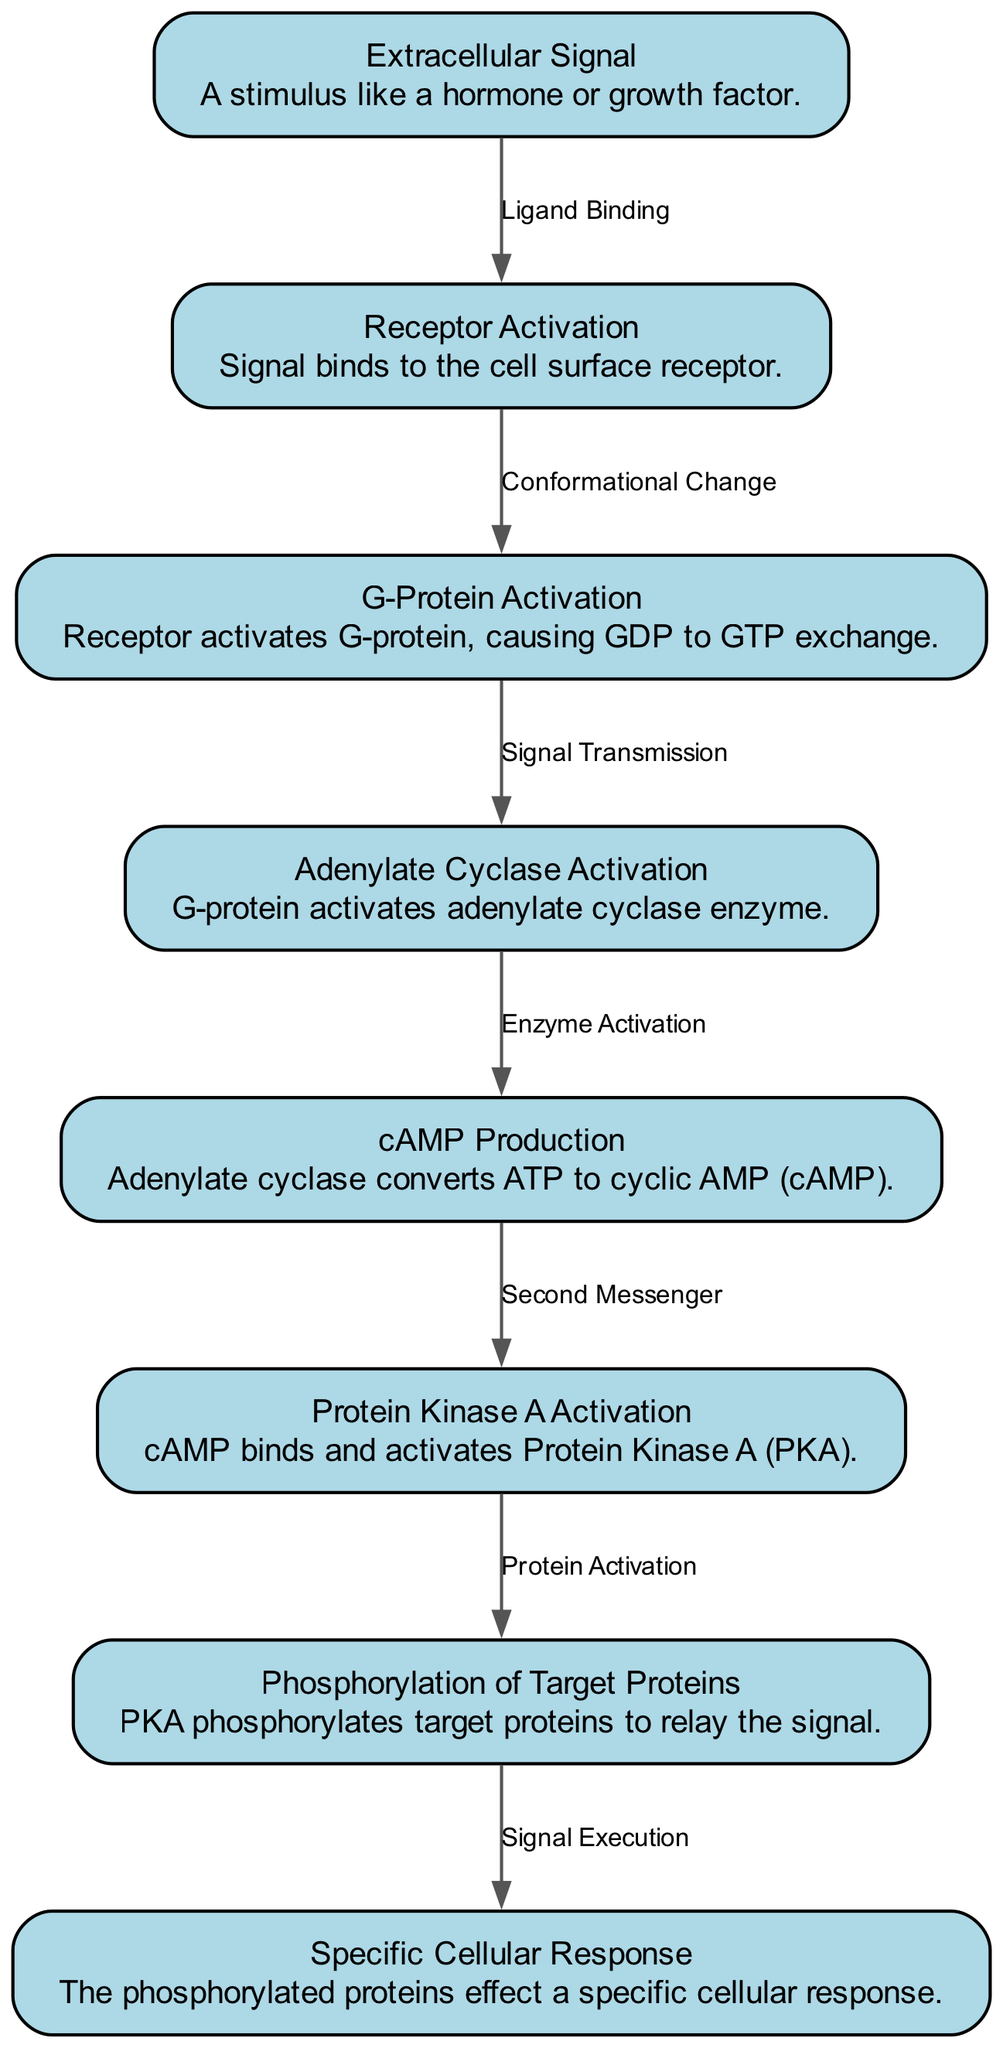What is the first node in the cascade? The first node is listed at the start of the sequence in the diagram. It is called "Extracellular Signal."
Answer: Extracellular Signal How many nodes are present in the signal transduction cascade? By counting the different nodes presented in the diagram, there are a total of eight nodes outlined from the stimulus to the cellular response.
Answer: 8 What is the relationship between Receptor Activation and G-Protein Activation? The edge connecting these nodes indicates a flow of information. The description of the edge states "Conformational Change," showing that the activation of the receptor leads to the activation of the G-protein.
Answer: Conformational Change Which node produces cAMP? The node responsible for generating cAMP in the cascade is identified specifically as "cAMP Production," which follows adenylate cyclase activation.
Answer: cAMP Production What is the final step in the signal transduction cascade? The last node in the sequence indicates the specific outcome of the cascade, labeled in the diagram as "Specific Cellular Response," where the signal effect is realized.
Answer: Specific Cellular Response What activates Protein Kinase A? As the diagram depicts, cAMP serves as a crucial second messenger that binds and activates Protein Kinase A, which is described directly in the respective node.
Answer: cAMP What happens immediately after G-Protein Activation? Following G-Protein Activation, the next node describes the process that occurs, which indicates that this G-protein activates adenylate cyclase.
Answer: Adenylate Cyclase Activation How are target proteins affected in the cascade? The edge from Protein Kinase A Activation to Phosphorylation of Target Proteins conveys that PKA modifies target proteins through phosphorylation, which is essential for signal relay.
Answer: Phosphorylation of Target Proteins 